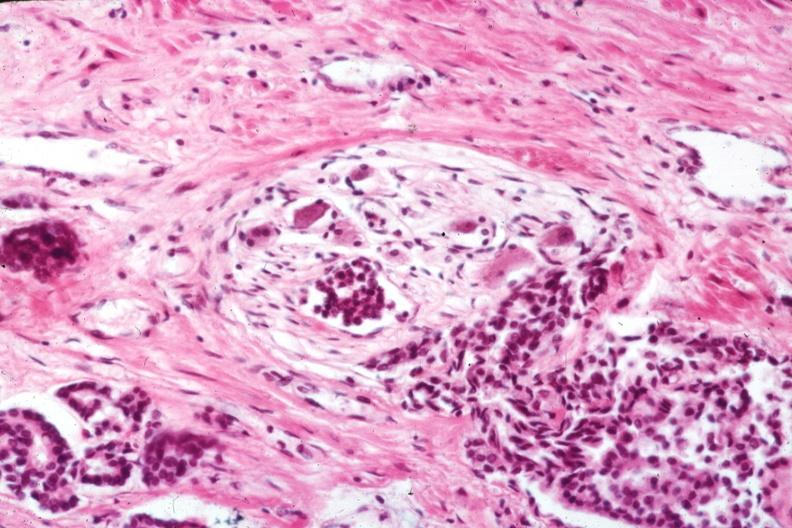s adenocarcinoma present?
Answer the question using a single word or phrase. Yes 